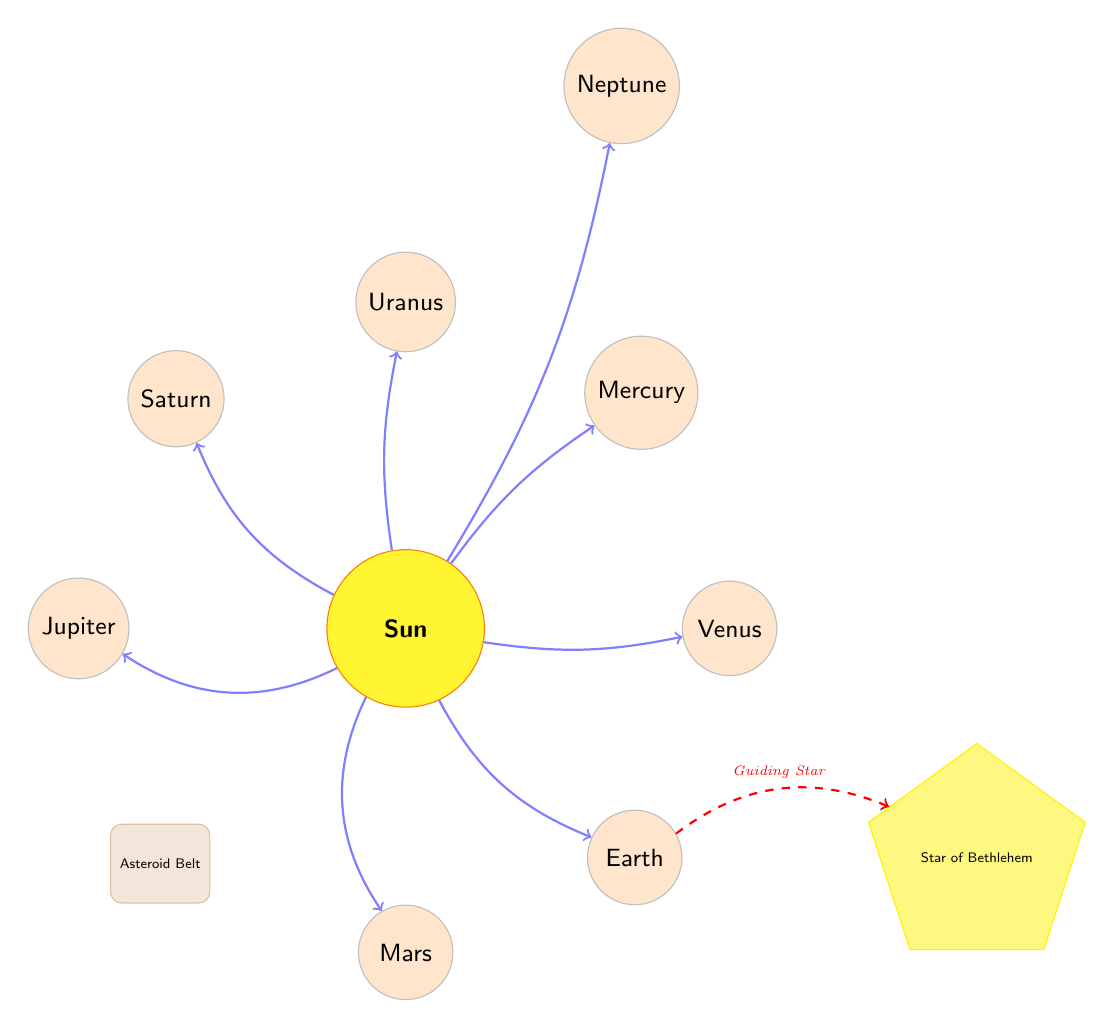What is the center of the solar system depicted in the diagram? The center of the solar system is represented by the largest circle labeled "Sun."
Answer: Sun Which planet is positioned closest to the sun? The planet closest to the sun is labeled "Mercury," which is directly above and to the right of the Sun.
Answer: Mercury How many planets are depicted in the solar system in the diagram? The diagram shows eight planets surrounding the Sun, which you can count based on the labeled nodes.
Answer: Eight What is the label of the object located directly to the right of the Earth? To the right of Earth, the label shown is "Star of Bethlehem."
Answer: Star of Bethlehem Which celestial body serves as a guiding star to the Earth? The guiding star referred to in the diagram is connected to Earth by a dashed red line labeled "Guiding Star."
Answer: Star of Bethlehem In total, how many objects are represented in the diagram (including planets, the Sun, and the asteroid belt)? By counting all labeled nodes (the Sun, eight planets, an asteroid belt, and the Star of Bethlehem), you find there are a total of ten distinct objects represented.
Answer: Ten What type of line connects the Earth to the Star of Bethlehem? A dashed red line is used to represent the connection between Earth and the Star of Bethlehem.
Answer: Dashed red line Which planet is shown directly below the Sun? The planet that is depicted directly below the Sun is labeled "Mars."
Answer: Mars What shapes are used to represent the planets in the diagram? The planets are represented as circles, while the Star of Bethlehem is depicted as a five-sided star shape.
Answer: Circles 